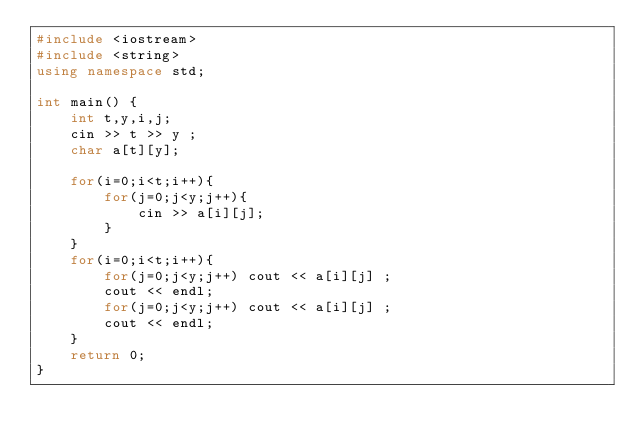<code> <loc_0><loc_0><loc_500><loc_500><_C++_>#include <iostream>
#include <string>
using namespace std;

int main() {
	int t,y,i,j;
	cin >> t >> y ;
	char a[t][y];
	
	for(i=0;i<t;i++){
		for(j=0;j<y;j++){
			cin >> a[i][j];
		}
	}
	for(i=0;i<t;i++){
		for(j=0;j<y;j++) cout << a[i][j] ;
		cout << endl;
		for(j=0;j<y;j++) cout << a[i][j] ;
		cout << endl;
	}
	return 0;
}</code> 